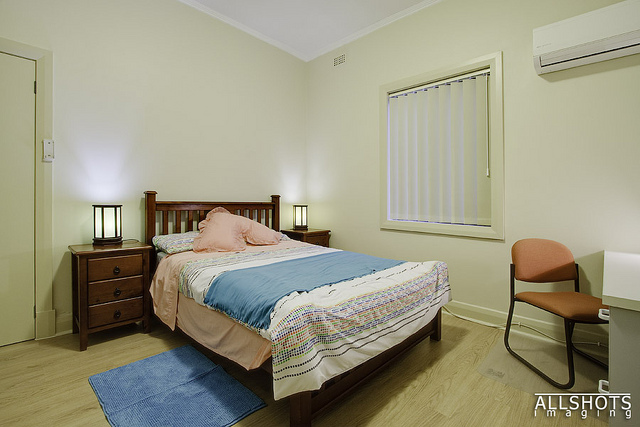Extract all visible text content from this image. ALLSHOTS IMAGING 